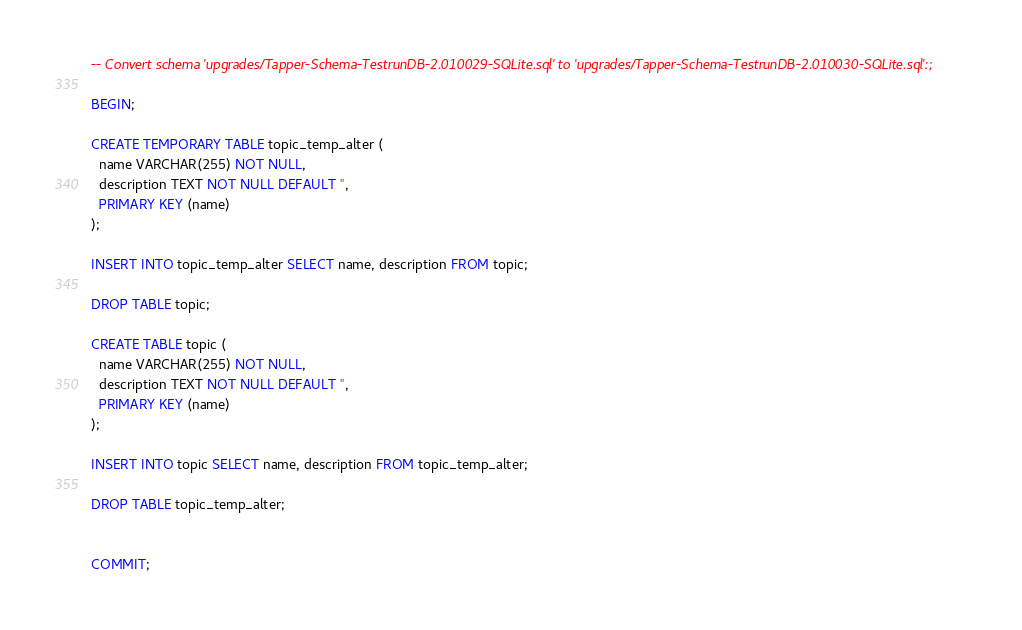<code> <loc_0><loc_0><loc_500><loc_500><_SQL_>-- Convert schema 'upgrades/Tapper-Schema-TestrunDB-2.010029-SQLite.sql' to 'upgrades/Tapper-Schema-TestrunDB-2.010030-SQLite.sql':;

BEGIN;

CREATE TEMPORARY TABLE topic_temp_alter (
  name VARCHAR(255) NOT NULL,
  description TEXT NOT NULL DEFAULT '',
  PRIMARY KEY (name)
);

INSERT INTO topic_temp_alter SELECT name, description FROM topic;

DROP TABLE topic;

CREATE TABLE topic (
  name VARCHAR(255) NOT NULL,
  description TEXT NOT NULL DEFAULT '',
  PRIMARY KEY (name)
);

INSERT INTO topic SELECT name, description FROM topic_temp_alter;

DROP TABLE topic_temp_alter;


COMMIT;

</code> 